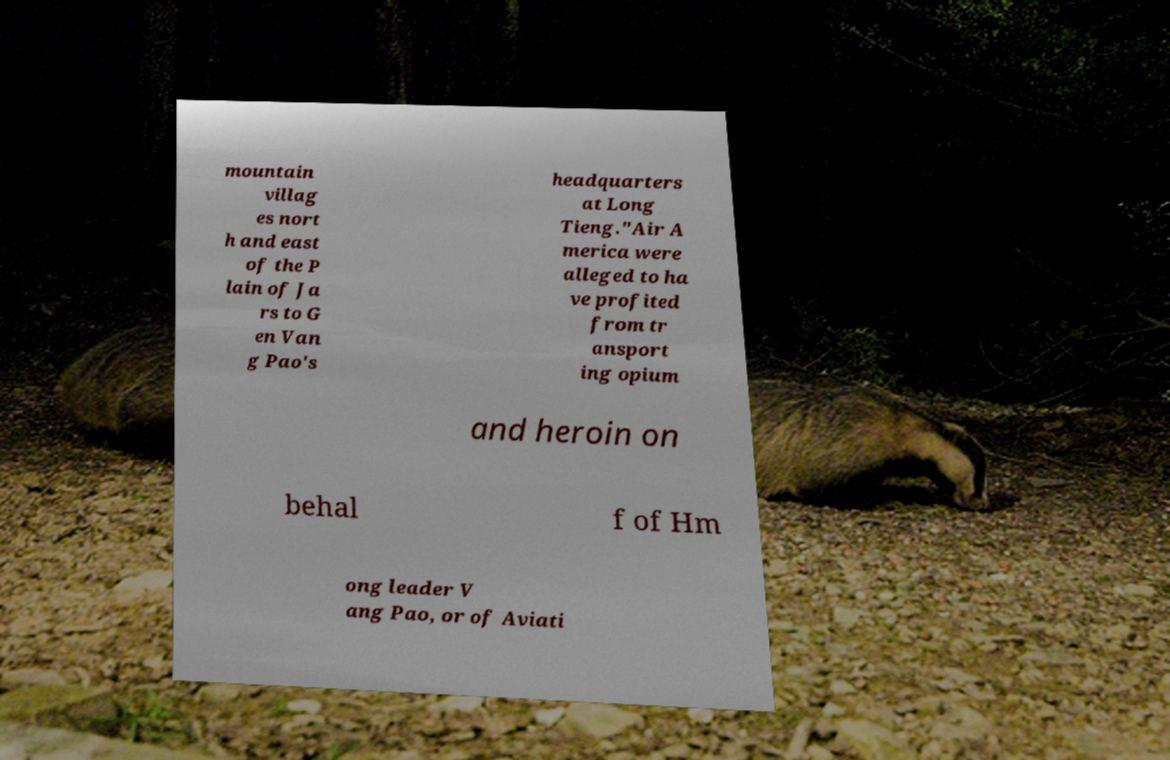I need the written content from this picture converted into text. Can you do that? mountain villag es nort h and east of the P lain of Ja rs to G en Van g Pao's headquarters at Long Tieng."Air A merica were alleged to ha ve profited from tr ansport ing opium and heroin on behal f of Hm ong leader V ang Pao, or of Aviati 